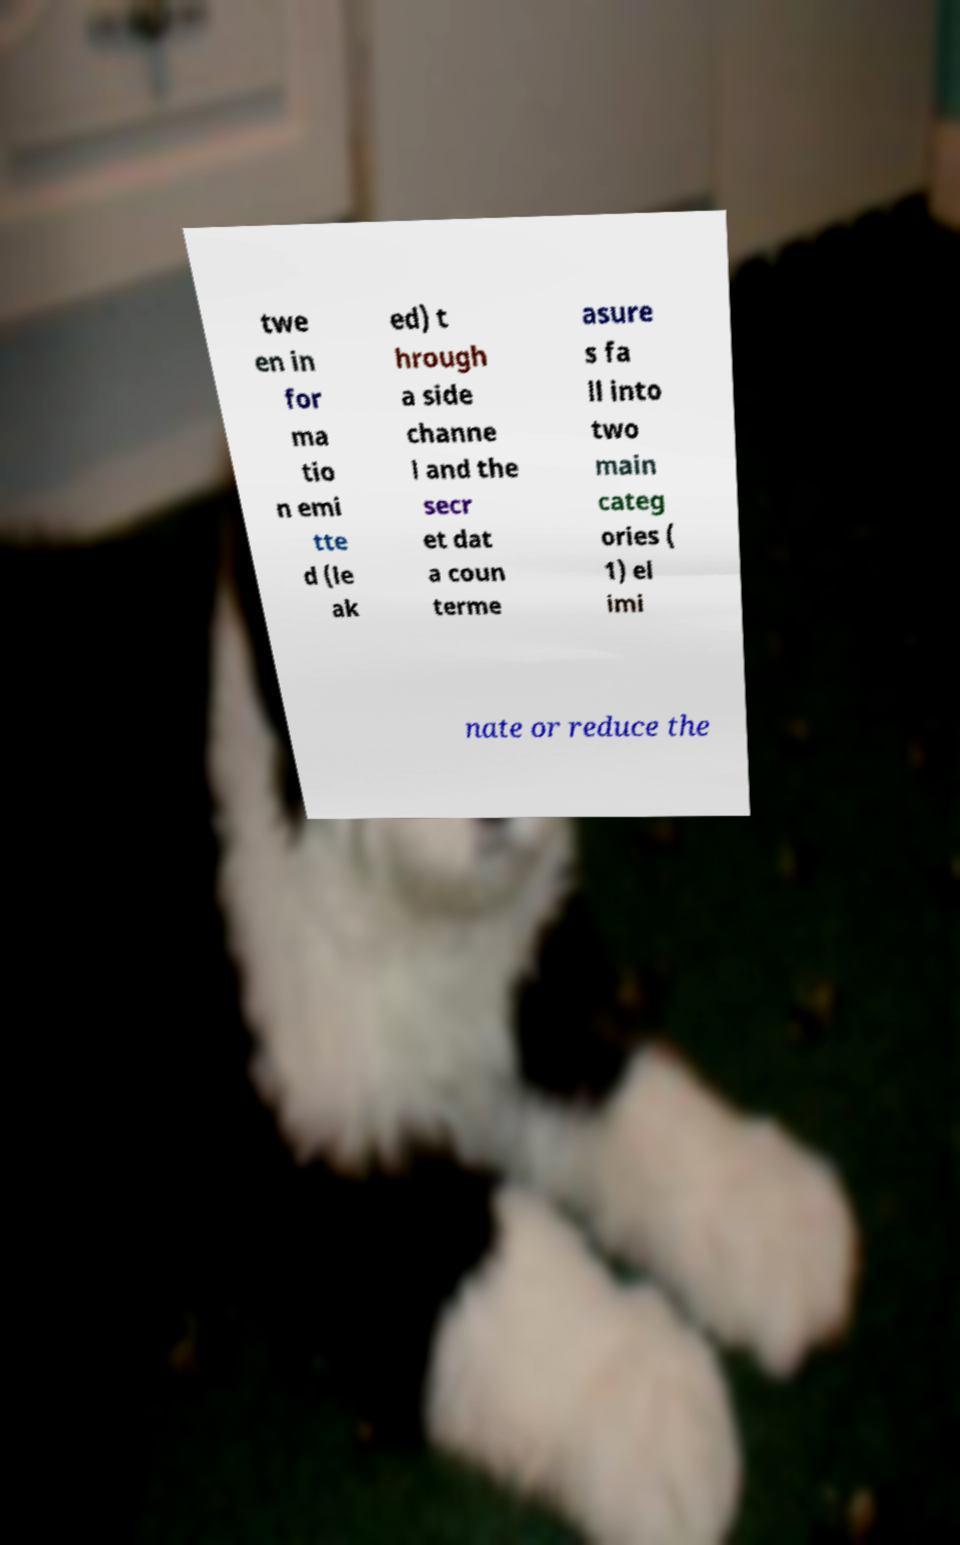For documentation purposes, I need the text within this image transcribed. Could you provide that? twe en in for ma tio n emi tte d (le ak ed) t hrough a side channe l and the secr et dat a coun terme asure s fa ll into two main categ ories ( 1) el imi nate or reduce the 